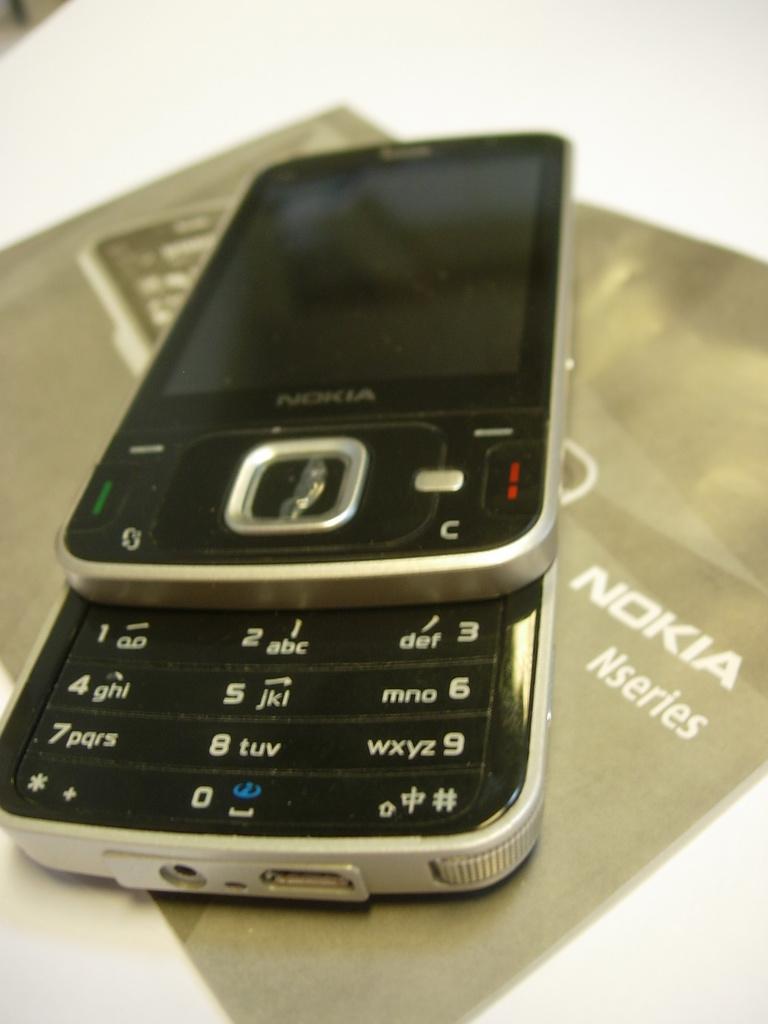What brand is the phone?
Provide a short and direct response. Nokia. What is the bottom left number on the phone?
Ensure brevity in your answer.  7. 